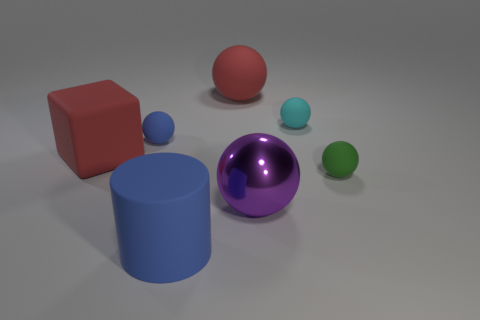What number of other shiny things have the same color as the metallic thing?
Provide a succinct answer. 0. What size is the blue object left of the cylinder left of the small cyan matte sphere?
Make the answer very short. Small. How many objects are either matte balls right of the cyan thing or purple shiny spheres?
Offer a very short reply. 2. Is there a blue metallic block of the same size as the cylinder?
Keep it short and to the point. No. Is there a ball that is to the right of the object in front of the large purple metal thing?
Offer a very short reply. Yes. What number of cylinders are either small green rubber things or large rubber things?
Your answer should be compact. 1. Is there another big metal object of the same shape as the large purple metallic object?
Your response must be concise. No. What is the shape of the cyan rubber object?
Your answer should be compact. Sphere. How many things are large blue cylinders or big matte balls?
Keep it short and to the point. 2. There is a ball that is in front of the green rubber object; is its size the same as the thing that is in front of the big shiny thing?
Provide a short and direct response. Yes. 